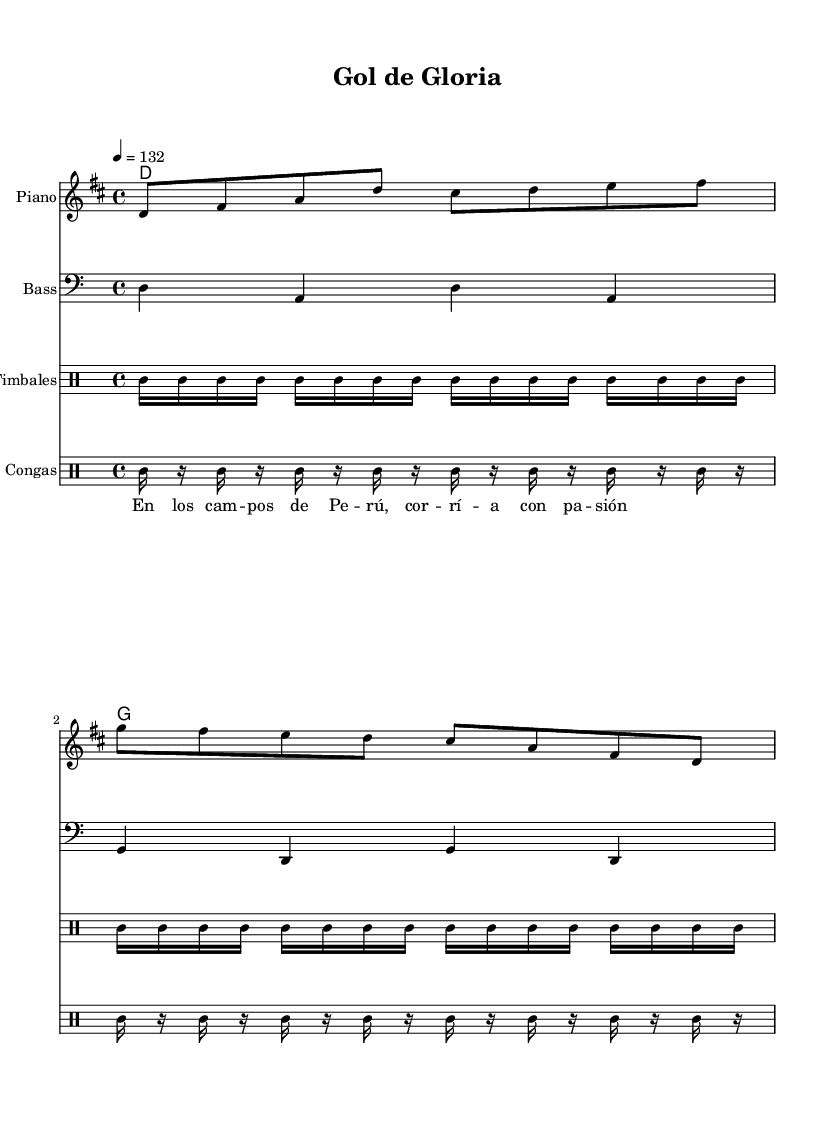What is the key signature of this music? The key signature is indicated at the beginning of the staff. Here, it shows two sharps, which corresponds to D major.
Answer: D major What is the time signature used in this piece? The time signature is also found at the beginning of the music. It shows 4 over 4, indicating that there are four beats in each measure and the quarter note gets one beat.
Answer: 4/4 What is the tempo marking for this piece? The tempo marking is written above the staff as "4 = 132," meaning there are 132 beats per minute. This sets a brisk pace for the piece.
Answer: 132 How many beats are in the first measure? The first measure contains a total of eight eighth notes, which sum up to four beats because each eighth note is half a beat in 4/4 time.
Answer: 4 What instruments are included in this score? The score lists four groups of instruments: Piano, Bass, Timbales, and Congas. This is evident from the instrument names indicated at the beginning of each staff.
Answer: Piano, Bass, Timbales, Congas What rhythmic pattern is used for the timbales? The rhythmic pattern for the timbales consists of a repeating series of sixteenth notes, indicated by the rhythmic notation for toms. The pattern clearly shows the repetitive nature of the rhythm typical in upbeat salsa music.
Answer: Sixteenth notes What are the lyrics celebrating? The lyrics celebrate a sense of excitement and passion associated with football, as they mention the fields of Peru and running with passion. This ties into the theme of athletic achievements.
Answer: Football and passion 